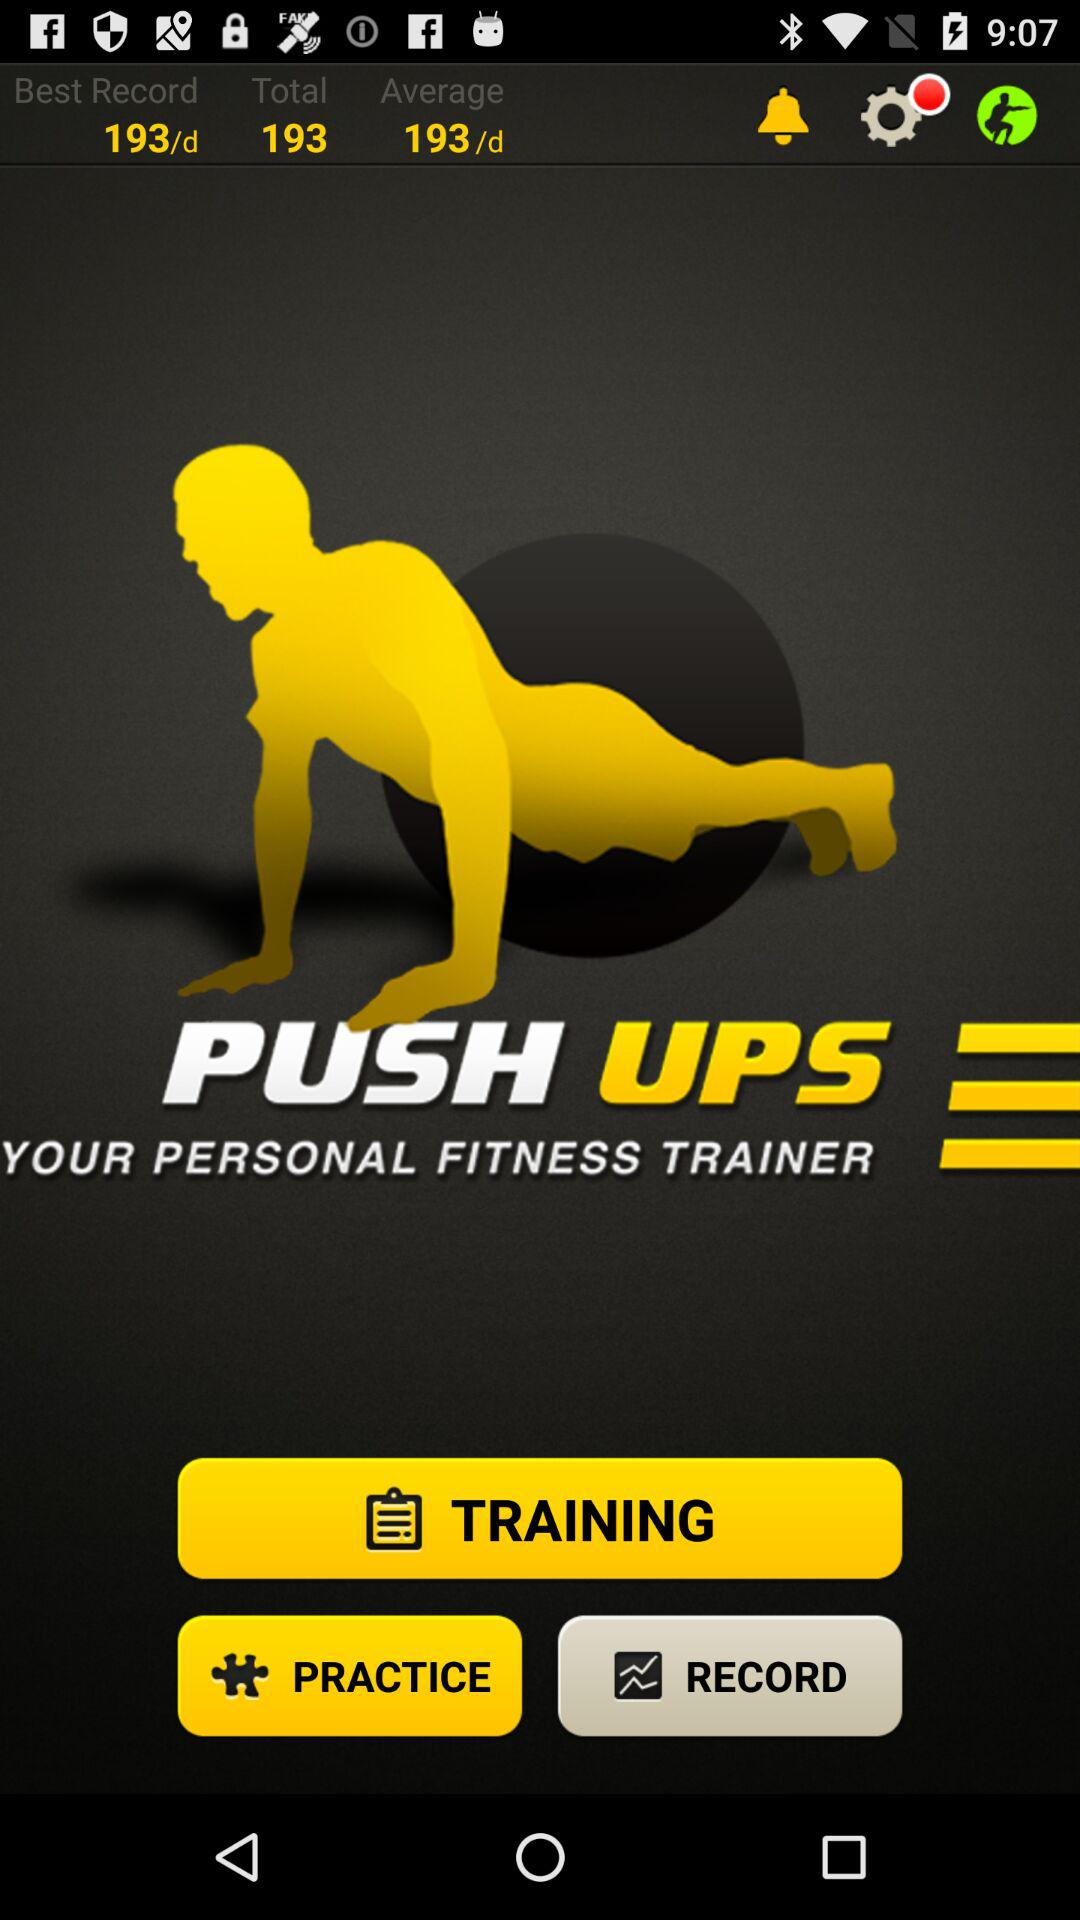How many notifications are in "Settings"?
When the provided information is insufficient, respond with <no answer>. <no answer> 